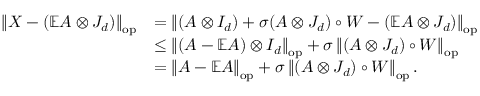Convert formula to latex. <formula><loc_0><loc_0><loc_500><loc_500>\begin{array} { r l } { \left \| { X - ( \mathbb { E } A \otimes J _ { d } ) } \right \| _ { o p } } & { = \left \| { ( A \otimes I _ { d } ) + \sigma ( A \otimes J _ { d } ) \circ W - ( \mathbb { E } A \otimes J _ { d } ) } \right \| _ { o p } } \\ & { \leq \left \| { ( A - \mathbb { E } A ) \otimes I _ { d } } \right \| _ { o p } + \sigma \left \| { ( A \otimes J _ { d } ) \circ W } \right \| _ { o p } } \\ & { = \left \| { A - \mathbb { E } A } \right \| _ { o p } + \sigma \left \| { ( A \otimes J _ { d } ) \circ W } \right \| _ { o p } . } \end{array}</formula> 